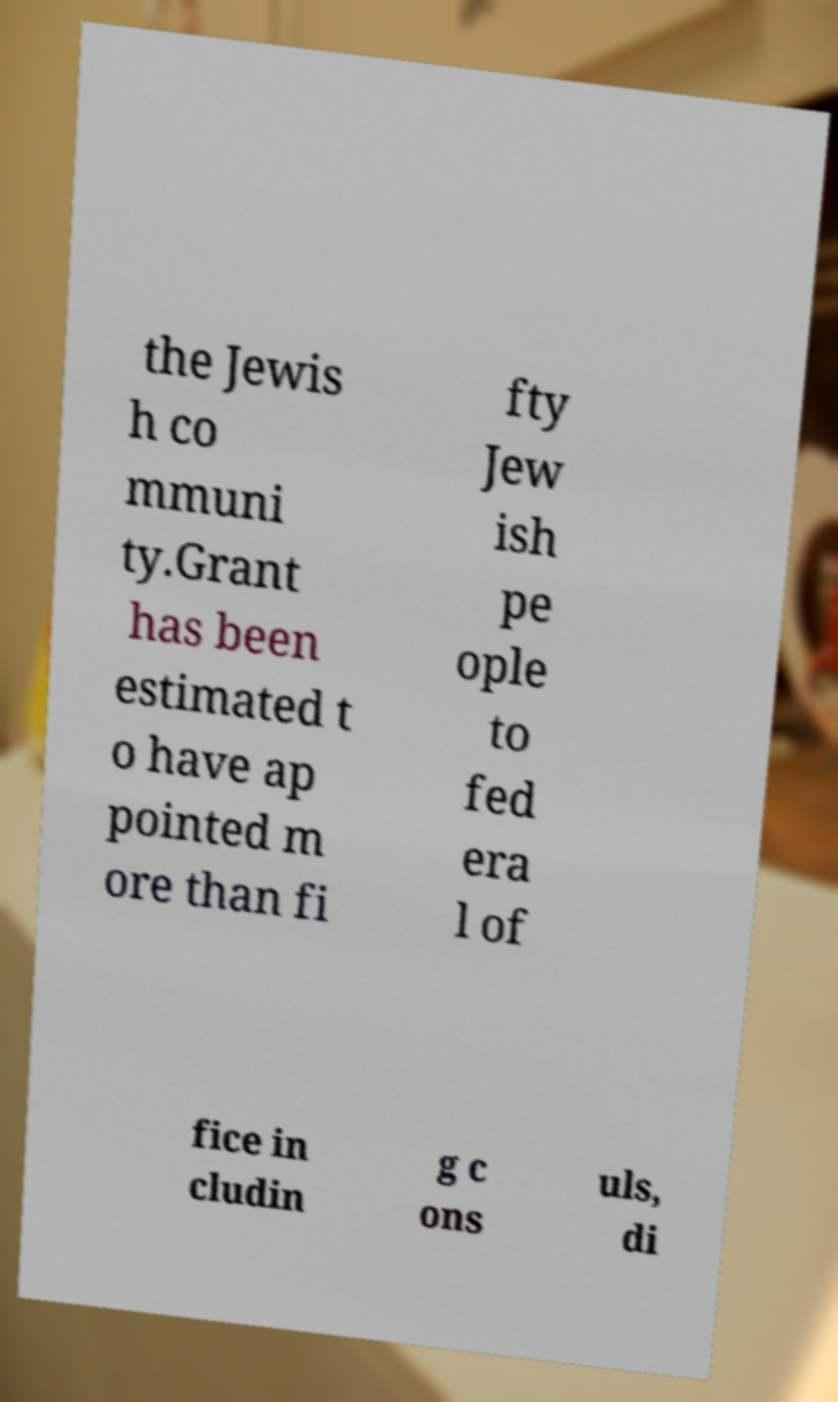There's text embedded in this image that I need extracted. Can you transcribe it verbatim? the Jewis h co mmuni ty.Grant has been estimated t o have ap pointed m ore than fi fty Jew ish pe ople to fed era l of fice in cludin g c ons uls, di 